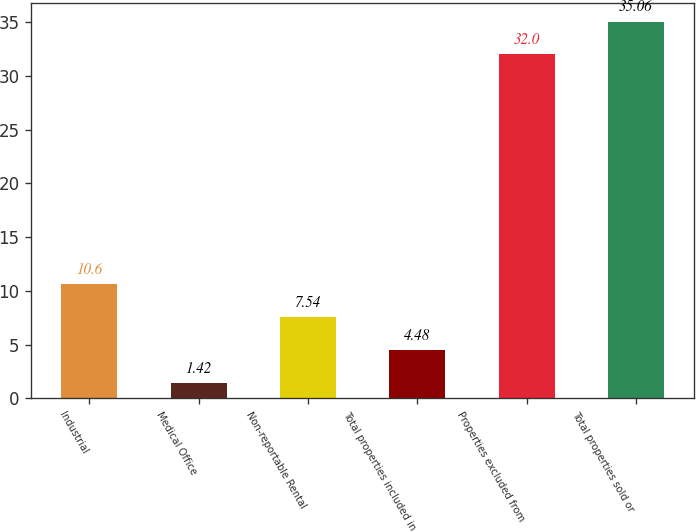<chart> <loc_0><loc_0><loc_500><loc_500><bar_chart><fcel>Industrial<fcel>Medical Office<fcel>Non-reportable Rental<fcel>Total properties included in<fcel>Properties excluded from<fcel>Total properties sold or<nl><fcel>10.6<fcel>1.42<fcel>7.54<fcel>4.48<fcel>32<fcel>35.06<nl></chart> 